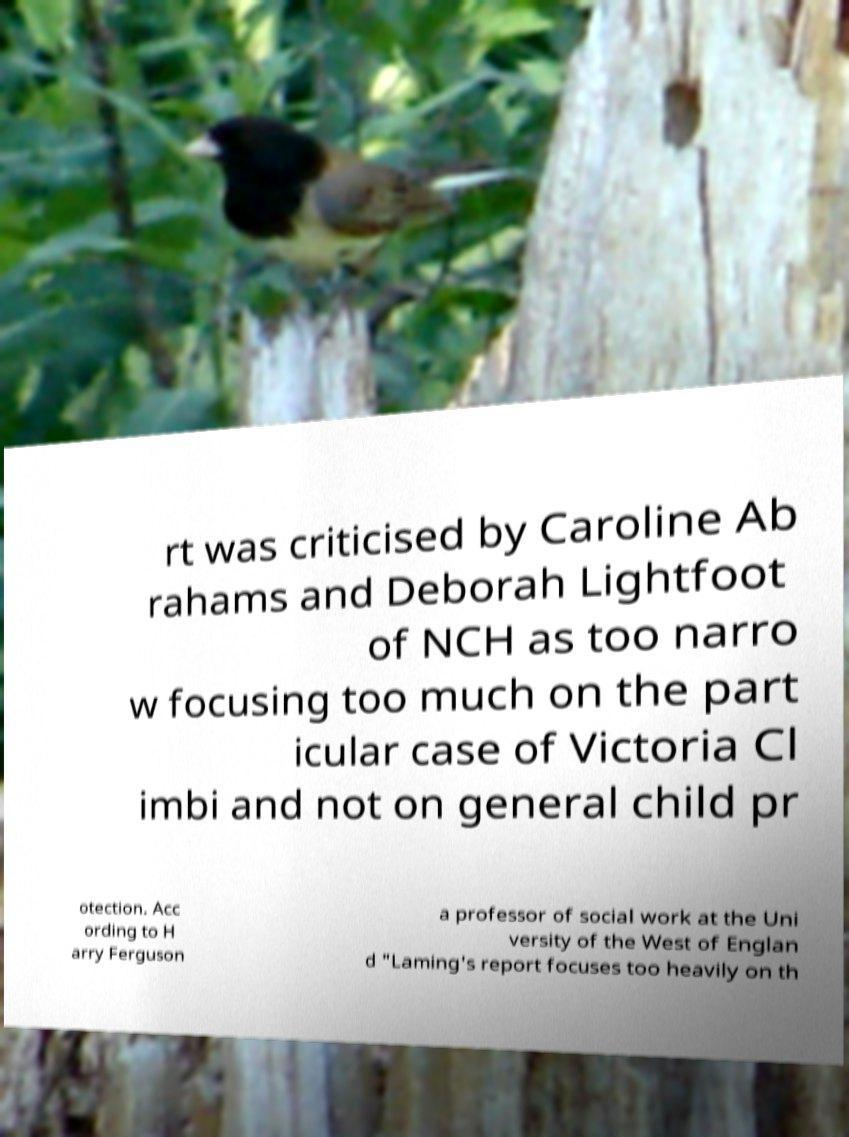There's text embedded in this image that I need extracted. Can you transcribe it verbatim? rt was criticised by Caroline Ab rahams and Deborah Lightfoot of NCH as too narro w focusing too much on the part icular case of Victoria Cl imbi and not on general child pr otection. Acc ording to H arry Ferguson a professor of social work at the Uni versity of the West of Englan d "Laming's report focuses too heavily on th 